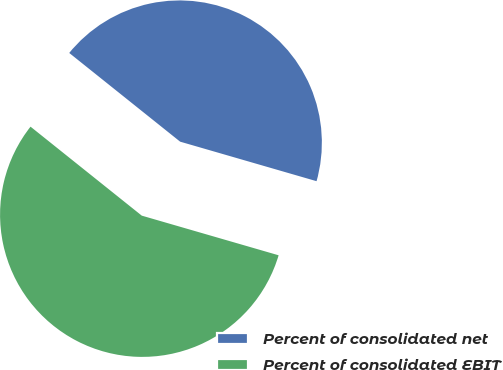<chart> <loc_0><loc_0><loc_500><loc_500><pie_chart><fcel>Percent of consolidated net<fcel>Percent of consolidated EBIT<nl><fcel>43.75%<fcel>56.25%<nl></chart> 